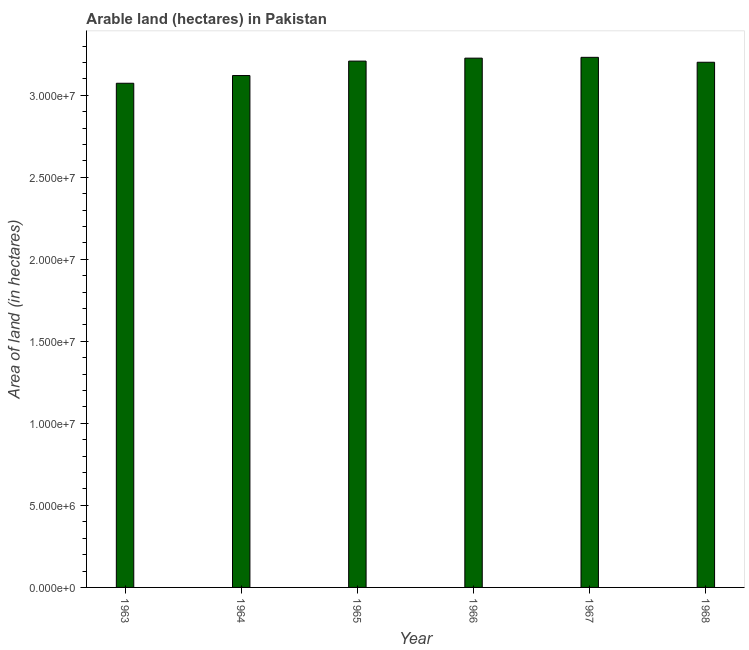Does the graph contain grids?
Keep it short and to the point. No. What is the title of the graph?
Ensure brevity in your answer.  Arable land (hectares) in Pakistan. What is the label or title of the Y-axis?
Your answer should be very brief. Area of land (in hectares). What is the area of land in 1968?
Provide a short and direct response. 3.20e+07. Across all years, what is the maximum area of land?
Provide a succinct answer. 3.23e+07. Across all years, what is the minimum area of land?
Provide a succinct answer. 3.07e+07. In which year was the area of land maximum?
Provide a succinct answer. 1967. What is the sum of the area of land?
Your answer should be very brief. 1.91e+08. What is the difference between the area of land in 1964 and 1967?
Keep it short and to the point. -1.11e+06. What is the average area of land per year?
Provide a succinct answer. 3.18e+07. What is the median area of land?
Your response must be concise. 3.20e+07. In how many years, is the area of land greater than 7000000 hectares?
Offer a very short reply. 6. Do a majority of the years between 1965 and 1963 (inclusive) have area of land greater than 28000000 hectares?
Keep it short and to the point. Yes. What is the ratio of the area of land in 1965 to that in 1966?
Provide a short and direct response. 0.99. What is the difference between the highest and the second highest area of land?
Make the answer very short. 5.00e+04. What is the difference between the highest and the lowest area of land?
Provide a short and direct response. 1.58e+06. In how many years, is the area of land greater than the average area of land taken over all years?
Offer a terse response. 4. How many bars are there?
Your response must be concise. 6. What is the difference between two consecutive major ticks on the Y-axis?
Offer a very short reply. 5.00e+06. Are the values on the major ticks of Y-axis written in scientific E-notation?
Give a very brief answer. Yes. What is the Area of land (in hectares) in 1963?
Offer a terse response. 3.07e+07. What is the Area of land (in hectares) of 1964?
Offer a very short reply. 3.12e+07. What is the Area of land (in hectares) of 1965?
Your answer should be compact. 3.21e+07. What is the Area of land (in hectares) in 1966?
Your answer should be very brief. 3.23e+07. What is the Area of land (in hectares) in 1967?
Offer a very short reply. 3.23e+07. What is the Area of land (in hectares) of 1968?
Your answer should be very brief. 3.20e+07. What is the difference between the Area of land (in hectares) in 1963 and 1964?
Give a very brief answer. -4.70e+05. What is the difference between the Area of land (in hectares) in 1963 and 1965?
Offer a very short reply. -1.35e+06. What is the difference between the Area of land (in hectares) in 1963 and 1966?
Your answer should be very brief. -1.53e+06. What is the difference between the Area of land (in hectares) in 1963 and 1967?
Your answer should be very brief. -1.58e+06. What is the difference between the Area of land (in hectares) in 1963 and 1968?
Offer a terse response. -1.28e+06. What is the difference between the Area of land (in hectares) in 1964 and 1965?
Make the answer very short. -8.80e+05. What is the difference between the Area of land (in hectares) in 1964 and 1966?
Give a very brief answer. -1.06e+06. What is the difference between the Area of land (in hectares) in 1964 and 1967?
Provide a short and direct response. -1.11e+06. What is the difference between the Area of land (in hectares) in 1964 and 1968?
Offer a very short reply. -8.10e+05. What is the difference between the Area of land (in hectares) in 1965 and 1966?
Provide a succinct answer. -1.80e+05. What is the difference between the Area of land (in hectares) in 1965 and 1967?
Your answer should be very brief. -2.30e+05. What is the difference between the Area of land (in hectares) in 1966 and 1967?
Offer a very short reply. -5.00e+04. What is the ratio of the Area of land (in hectares) in 1963 to that in 1964?
Give a very brief answer. 0.98. What is the ratio of the Area of land (in hectares) in 1963 to that in 1965?
Offer a terse response. 0.96. What is the ratio of the Area of land (in hectares) in 1963 to that in 1966?
Your answer should be compact. 0.95. What is the ratio of the Area of land (in hectares) in 1963 to that in 1967?
Offer a terse response. 0.95. What is the ratio of the Area of land (in hectares) in 1964 to that in 1968?
Provide a short and direct response. 0.97. What is the ratio of the Area of land (in hectares) in 1965 to that in 1966?
Your answer should be very brief. 0.99. What is the ratio of the Area of land (in hectares) in 1966 to that in 1967?
Ensure brevity in your answer.  1. What is the ratio of the Area of land (in hectares) in 1967 to that in 1968?
Give a very brief answer. 1.01. 